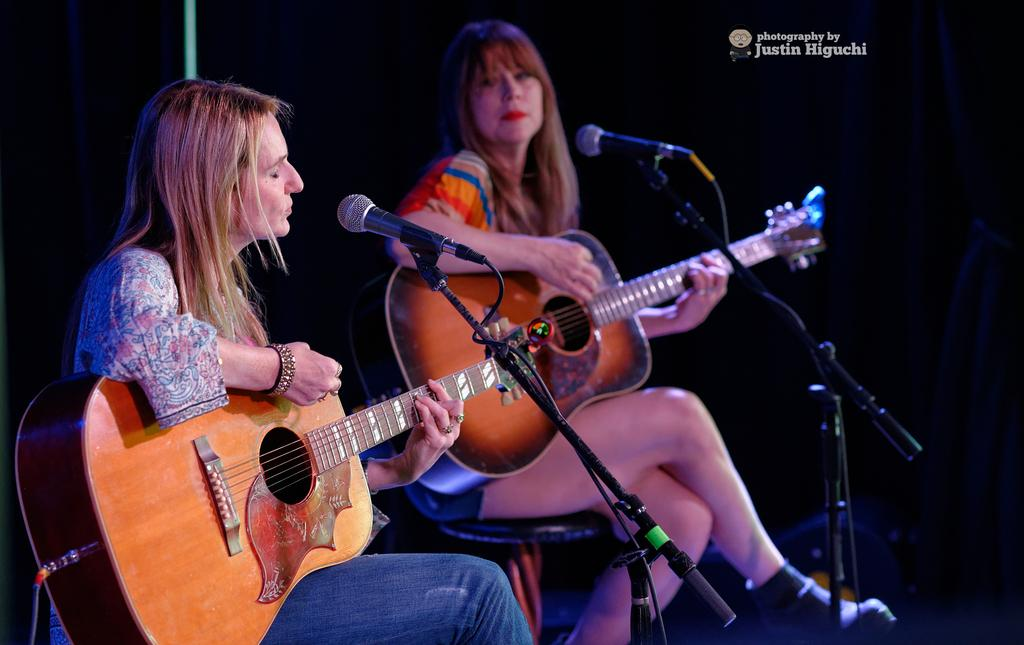How many people are in the image? There are two women in the image. What are the women doing in the image? The women are sitting on chairs and holding guitars. What objects are in front of the women? There are two microphones in front of the women. Can you tell me how many donkeys are visible in the image? There are no donkeys present in the image. What type of ear is shown on the women in the image? The image does not show the women's ears, so it cannot be determined what type of ear they have. 